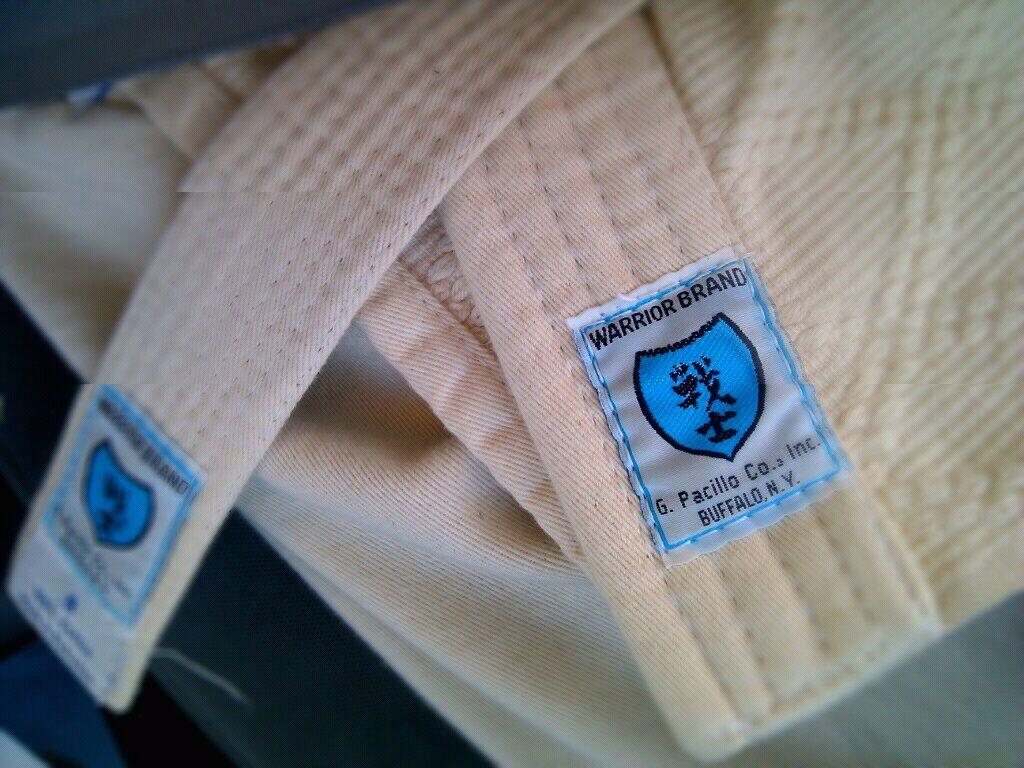What object can be seen in the image? There is a belt in the image. What type of yam is being used as a decoration in the image? There is no yam present in the image; it only features a belt. What events are scheduled for the upcoming week according to the calendar in the image? There is no calendar present in the image, only a belt. 